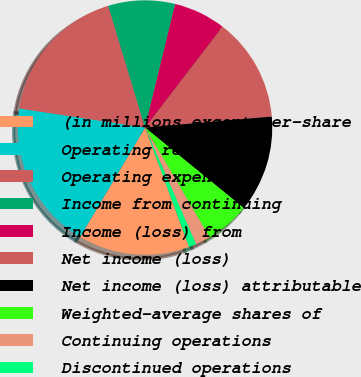Convert chart to OTSL. <chart><loc_0><loc_0><loc_500><loc_500><pie_chart><fcel>(in millions except per-share<fcel>Operating revenue<fcel>Operating expenses<fcel>Income from continuing<fcel>Income (loss) from<fcel>Net income (loss)<fcel>Net income (loss) attributable<fcel>Weighted-average shares of<fcel>Continuing operations<fcel>Discontinued operations<nl><fcel>14.15%<fcel>18.87%<fcel>17.92%<fcel>8.49%<fcel>6.6%<fcel>13.21%<fcel>12.26%<fcel>5.66%<fcel>1.89%<fcel>0.94%<nl></chart> 